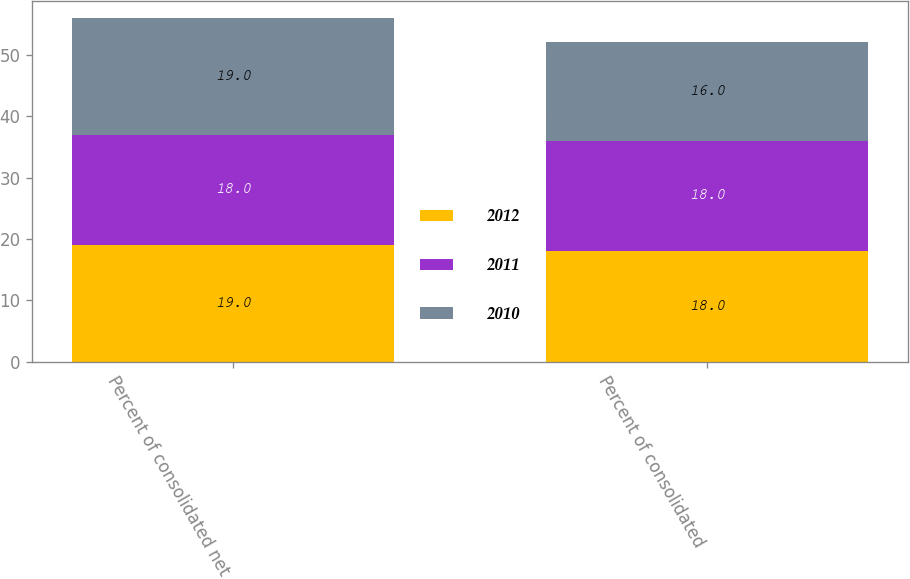Convert chart. <chart><loc_0><loc_0><loc_500><loc_500><stacked_bar_chart><ecel><fcel>Percent of consolidated net<fcel>Percent of consolidated<nl><fcel>2012<fcel>19<fcel>18<nl><fcel>2011<fcel>18<fcel>18<nl><fcel>2010<fcel>19<fcel>16<nl></chart> 